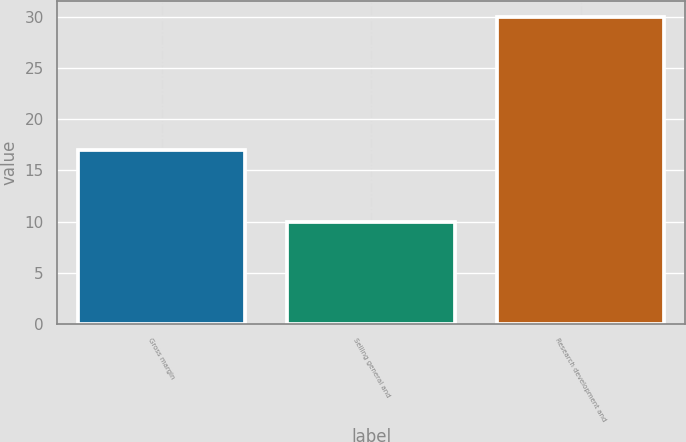Convert chart to OTSL. <chart><loc_0><loc_0><loc_500><loc_500><bar_chart><fcel>Gross margin<fcel>Selling general and<fcel>Research development and<nl><fcel>17<fcel>10<fcel>30<nl></chart> 